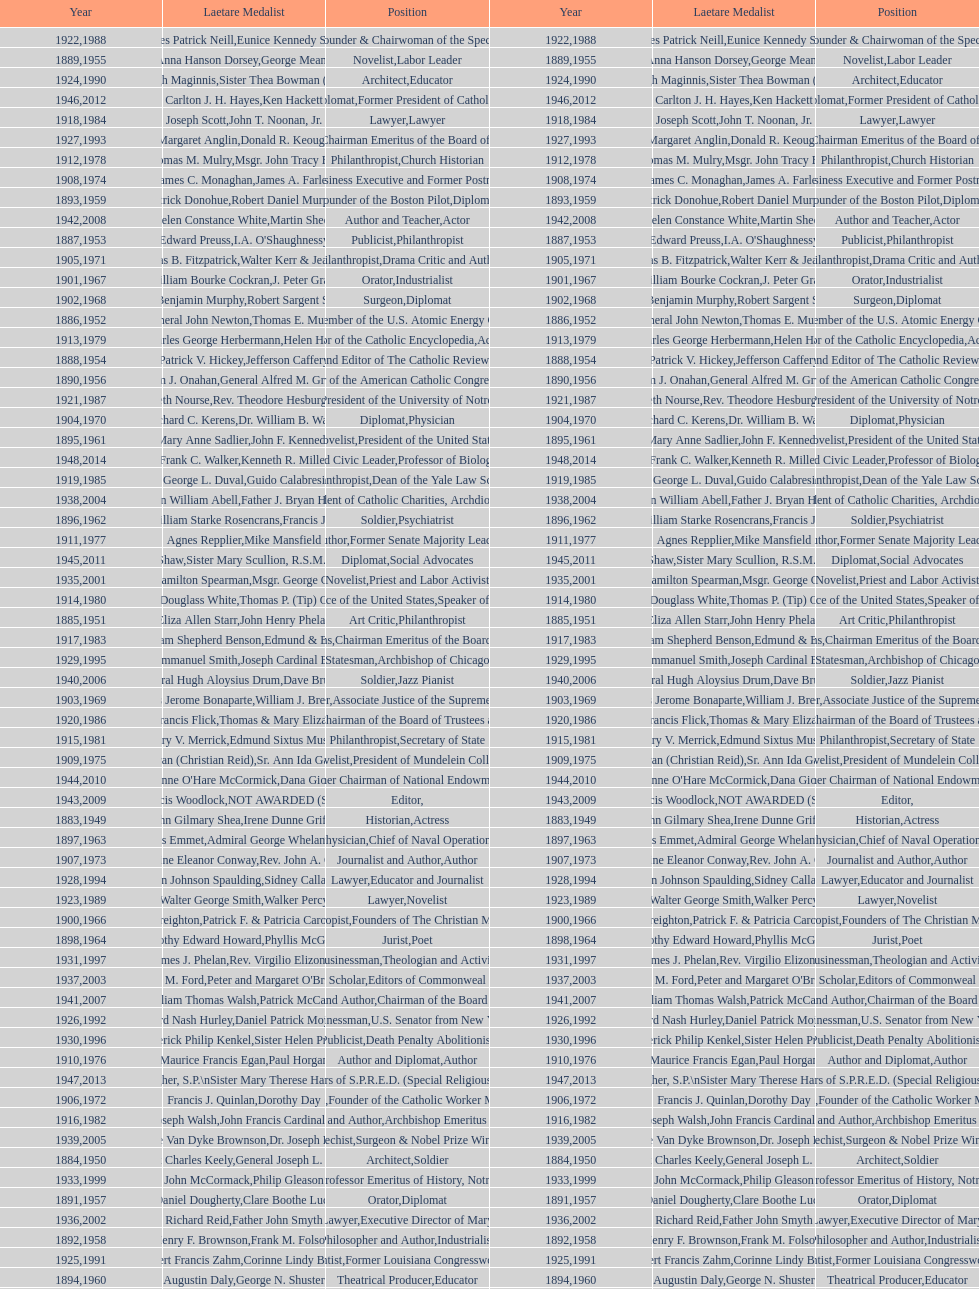How many are or were journalists? 5. 